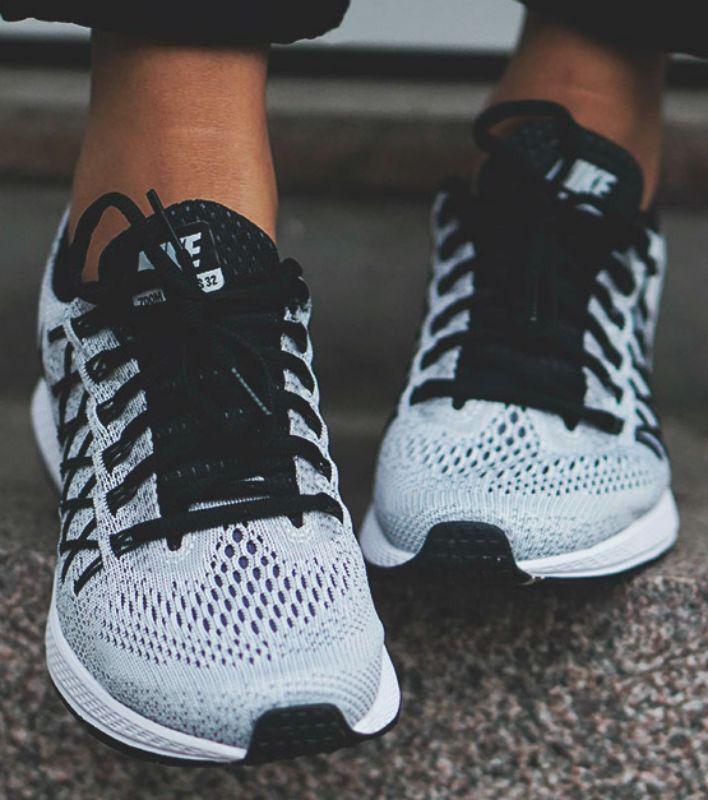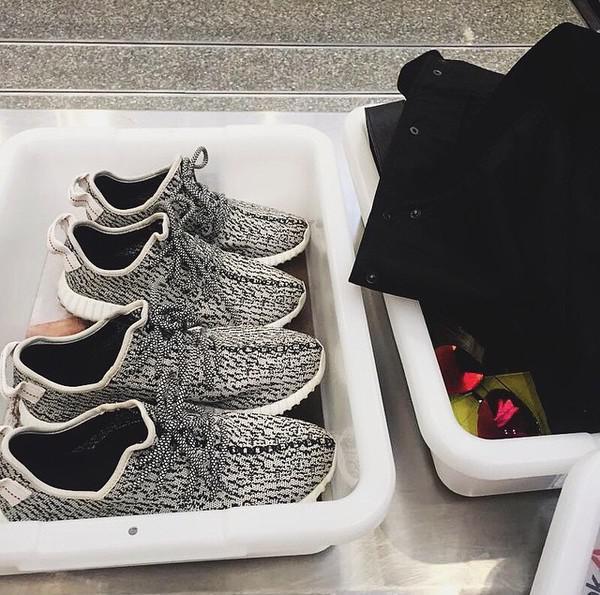The first image is the image on the left, the second image is the image on the right. Considering the images on both sides, is "A total of three shoes are shown." valid? Answer yes or no. No. 